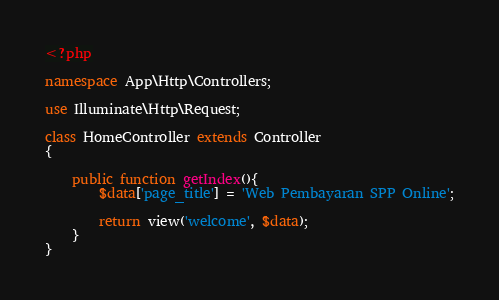Convert code to text. <code><loc_0><loc_0><loc_500><loc_500><_PHP_><?php

namespace App\Http\Controllers;

use Illuminate\Http\Request;

class HomeController extends Controller
{

    public function getIndex(){
        $data['page_title'] = 'Web Pembayaran SPP Online';

        return view('welcome', $data);
    }
}
</code> 